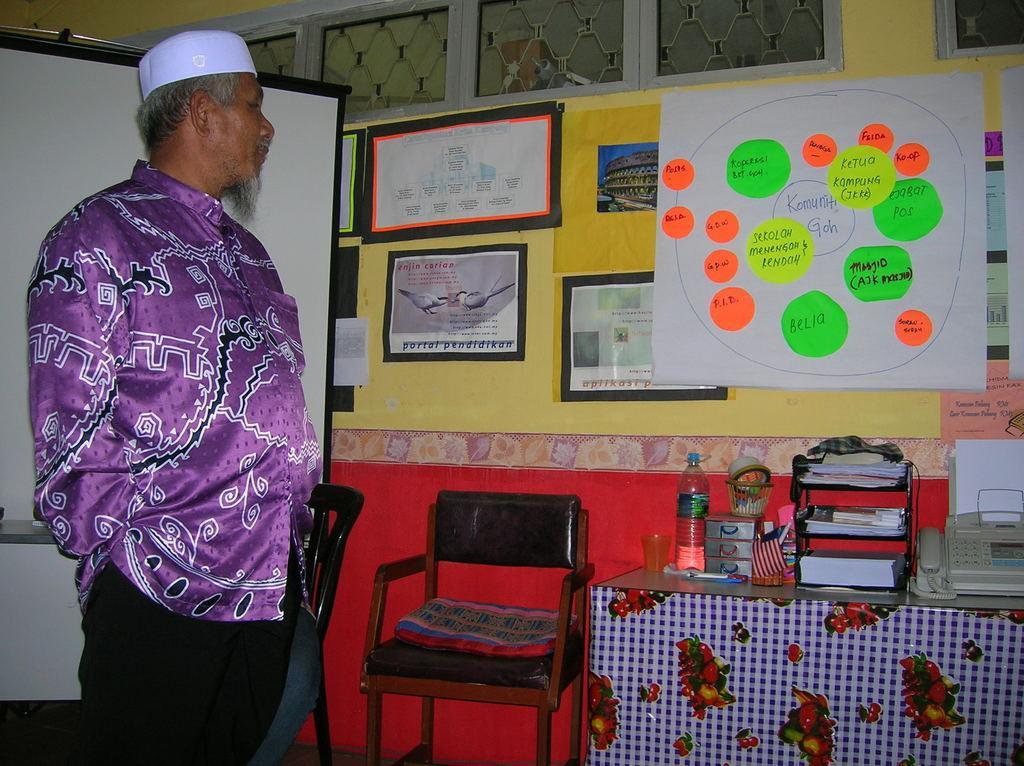Please provide a concise description of this image. In this image, there is a man in the left. The image is clicked in a room. In the background, there is a wall on which, some frames and charts are fixed. At the bottom, there is a table on which a bottle, telephone, and some boxes are kept. In the middle, there is a chair. To the left, there is a board behind the man. 